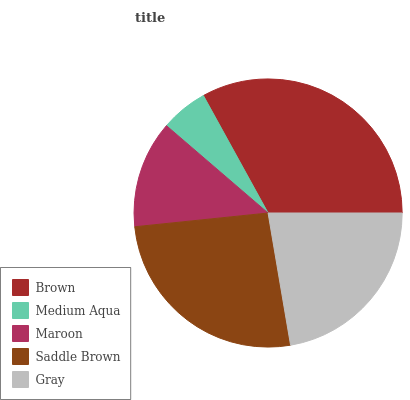Is Medium Aqua the minimum?
Answer yes or no. Yes. Is Brown the maximum?
Answer yes or no. Yes. Is Maroon the minimum?
Answer yes or no. No. Is Maroon the maximum?
Answer yes or no. No. Is Maroon greater than Medium Aqua?
Answer yes or no. Yes. Is Medium Aqua less than Maroon?
Answer yes or no. Yes. Is Medium Aqua greater than Maroon?
Answer yes or no. No. Is Maroon less than Medium Aqua?
Answer yes or no. No. Is Gray the high median?
Answer yes or no. Yes. Is Gray the low median?
Answer yes or no. Yes. Is Maroon the high median?
Answer yes or no. No. Is Maroon the low median?
Answer yes or no. No. 